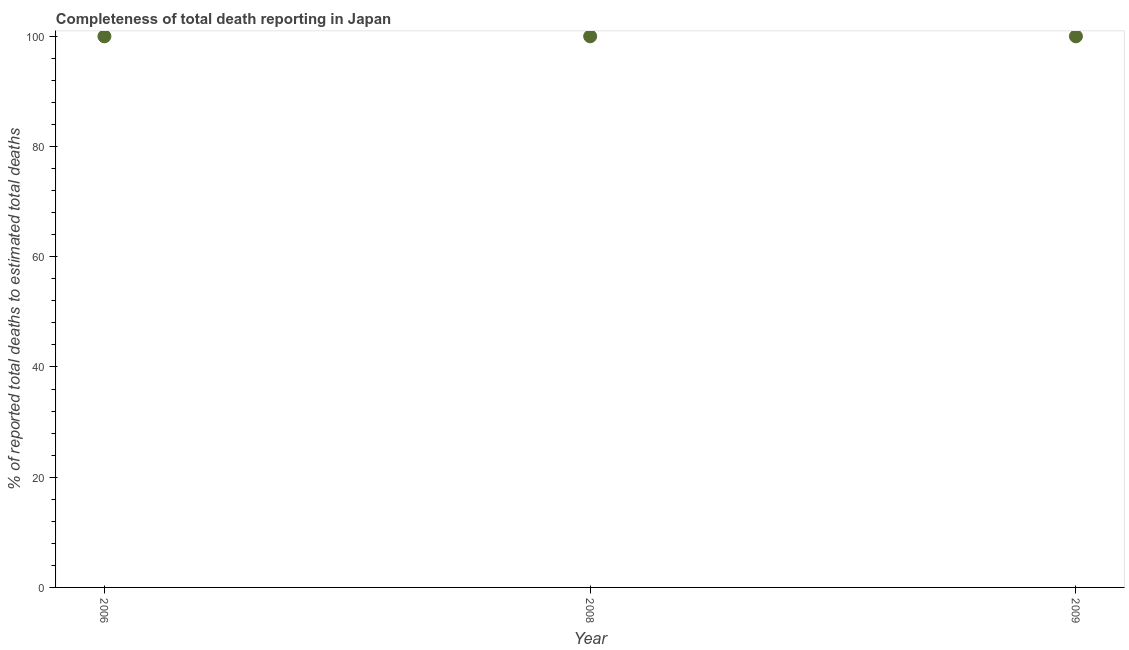What is the completeness of total death reports in 2009?
Offer a terse response. 100. Across all years, what is the maximum completeness of total death reports?
Make the answer very short. 100. Across all years, what is the minimum completeness of total death reports?
Provide a short and direct response. 100. In which year was the completeness of total death reports maximum?
Your response must be concise. 2006. What is the sum of the completeness of total death reports?
Offer a very short reply. 300. What is the median completeness of total death reports?
Your answer should be compact. 100. What is the ratio of the completeness of total death reports in 2008 to that in 2009?
Provide a succinct answer. 1. Is the completeness of total death reports in 2008 less than that in 2009?
Ensure brevity in your answer.  No. Is the difference between the completeness of total death reports in 2008 and 2009 greater than the difference between any two years?
Provide a short and direct response. Yes. What is the difference between the highest and the second highest completeness of total death reports?
Your answer should be very brief. 0. What is the difference between the highest and the lowest completeness of total death reports?
Your response must be concise. 0. In how many years, is the completeness of total death reports greater than the average completeness of total death reports taken over all years?
Offer a very short reply. 0. Does the completeness of total death reports monotonically increase over the years?
Provide a short and direct response. No. How many dotlines are there?
Make the answer very short. 1. How many years are there in the graph?
Make the answer very short. 3. What is the difference between two consecutive major ticks on the Y-axis?
Your response must be concise. 20. What is the title of the graph?
Offer a very short reply. Completeness of total death reporting in Japan. What is the label or title of the X-axis?
Ensure brevity in your answer.  Year. What is the label or title of the Y-axis?
Your answer should be compact. % of reported total deaths to estimated total deaths. What is the % of reported total deaths to estimated total deaths in 2008?
Keep it short and to the point. 100. What is the difference between the % of reported total deaths to estimated total deaths in 2008 and 2009?
Ensure brevity in your answer.  0. What is the ratio of the % of reported total deaths to estimated total deaths in 2006 to that in 2009?
Ensure brevity in your answer.  1. 